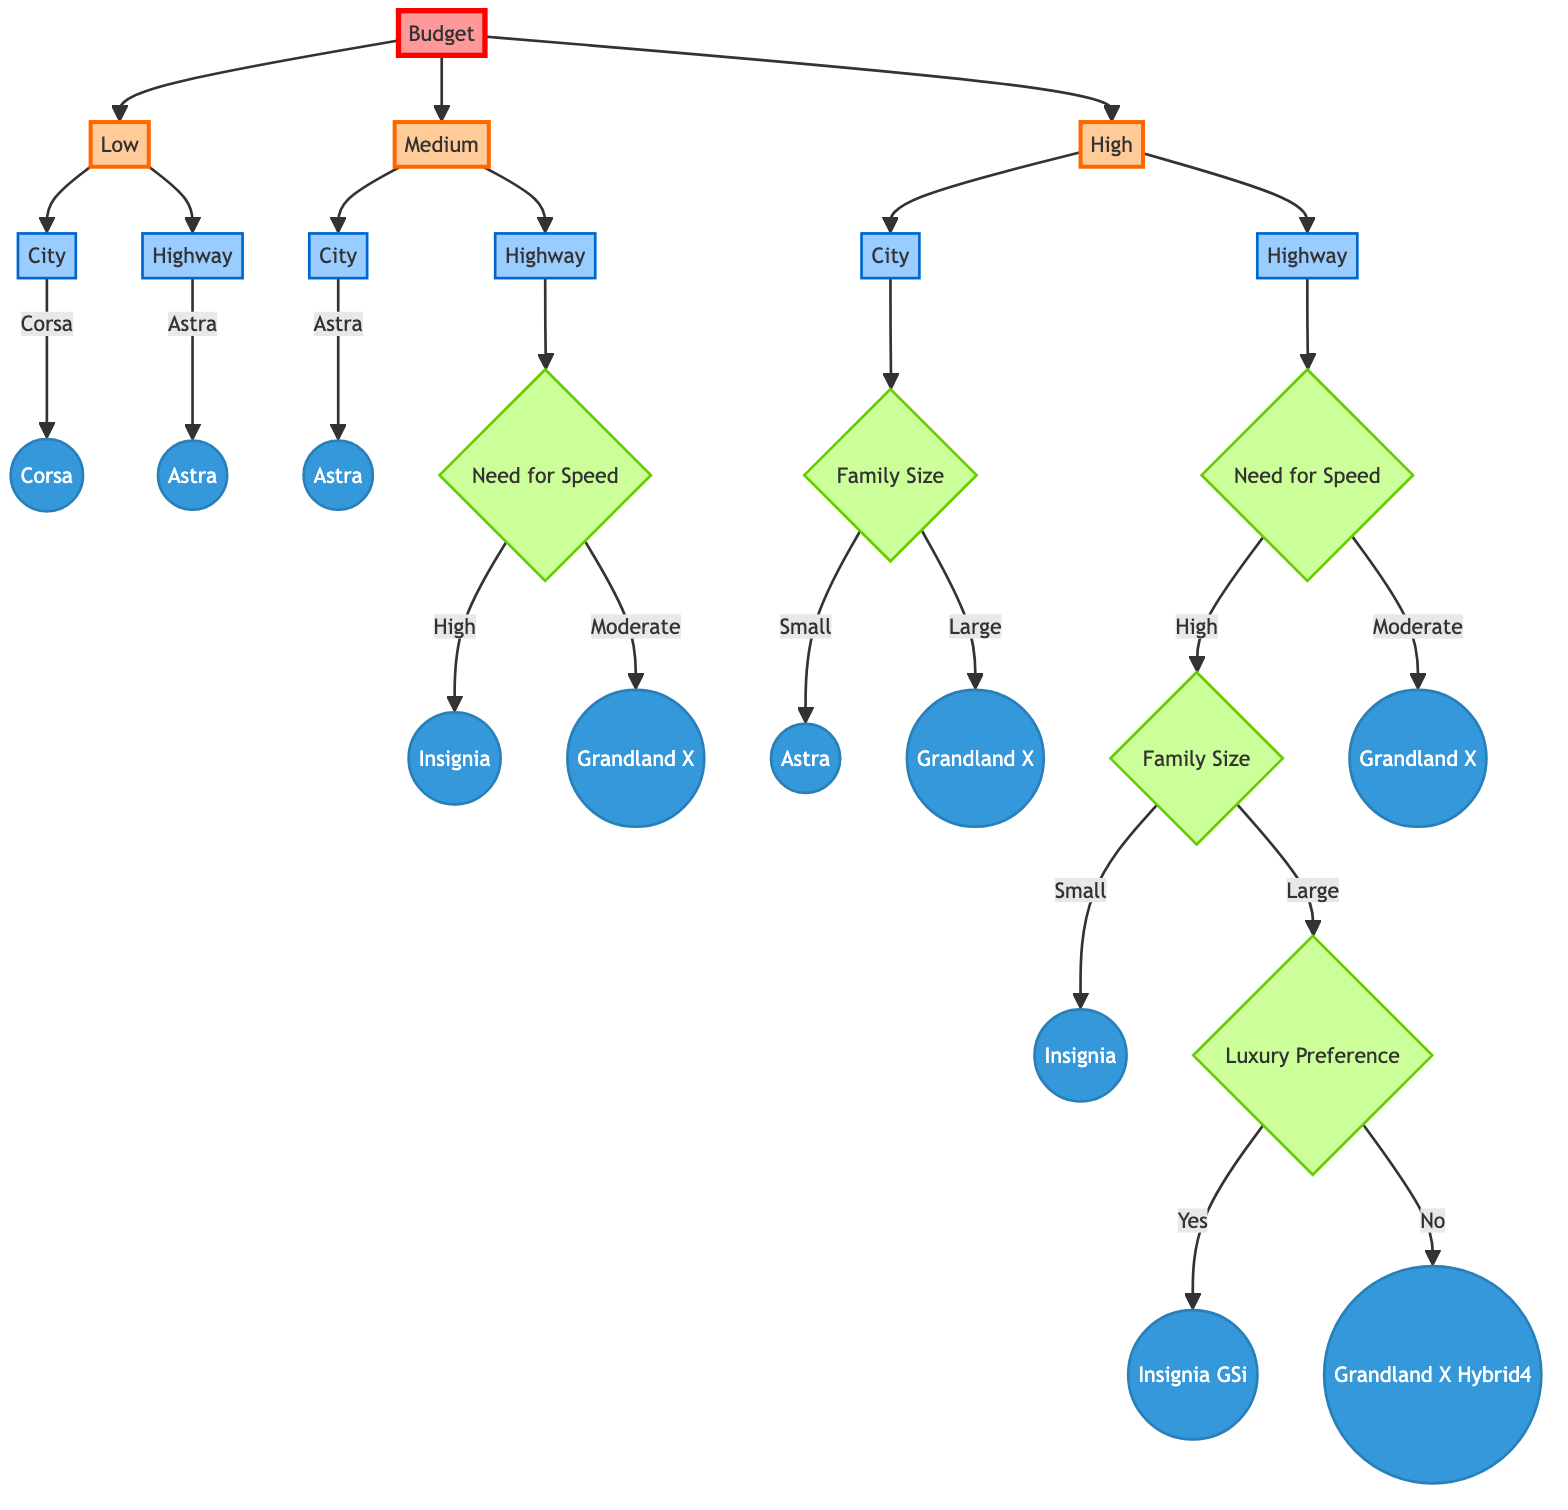What is the recommended model for a low budget in a city driving environment? For a low budget, the decision tree indicates that in a city driving environment, the recommended model is the Vauxhall Corsa.
Answer: Vauxhall Corsa What is the main decision criterion for high budget options? The main decision criterion for high budget options is the driving environment, which branches into city and highway.
Answer: Driving Environment Which model is recommended for a medium budget needing high speed on the highway? For a medium budget needing high speed on the highway, the decision tree recommends the Vauxhall Insignia.
Answer: Vauxhall Insignia How many total vehicles are recommended in the tree? The tree recommends a total of six different vehicles based on varying criteria.
Answer: Six If the driving condition is on a highway with a moderate need for speed and a high budget, what is the recommended model? Following the path for a high budget and a highway driving environment with a moderate need for speed, the vehicle recommended is the Vauxhall Grandland X.
Answer: Vauxhall Grandland X What is the outcome for a high budget in a city environment with a large family size? For a high budget in a city environment with a large family size, the outcome is the Vauxhall Grandland X.
Answer: Vauxhall Grandland X What classification follows the node labeled "Need for Speed" for high speed with a large family in a highway environment? The classification follows to the node regarding luxury preference, which further divides the outcomes into the Vauxhall Insignia GSi or Vauxhall Grandland X Hybrid4.
Answer: Luxury Preference Which model is recommended if the need for speed is moderate on the highway with a high budget? If the need for speed is moderate on the highway with a high budget, the recommended model is the Vauxhall Grandland X.
Answer: Vauxhall Grandland X 